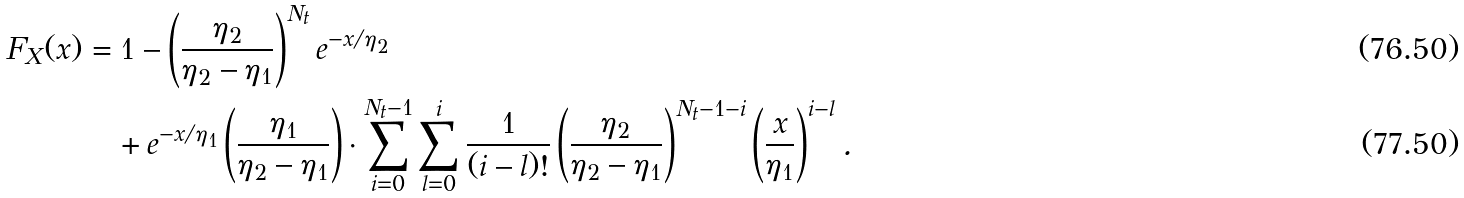<formula> <loc_0><loc_0><loc_500><loc_500>F _ { X } ( x ) & = 1 - \left ( \frac { \eta _ { 2 } } { \eta _ { 2 } - \eta _ { 1 } } \right ) ^ { N _ { t } } e ^ { - x / \eta _ { 2 } } \\ & \quad + e ^ { - x / \eta _ { 1 } } \left ( \frac { \eta _ { 1 } } { \eta _ { 2 } - \eta _ { 1 } } \right ) \cdot \sum _ { i = 0 } ^ { N _ { t } - 1 } \sum _ { l = 0 } ^ { i } \frac { 1 } { ( i - l ) ! } \left ( \frac { \eta _ { 2 } } { \eta _ { 2 } - \eta _ { 1 } } \right ) ^ { N _ { t } - 1 - i } \left ( \frac { x } { \eta _ { 1 } } \right ) ^ { i - l } .</formula> 